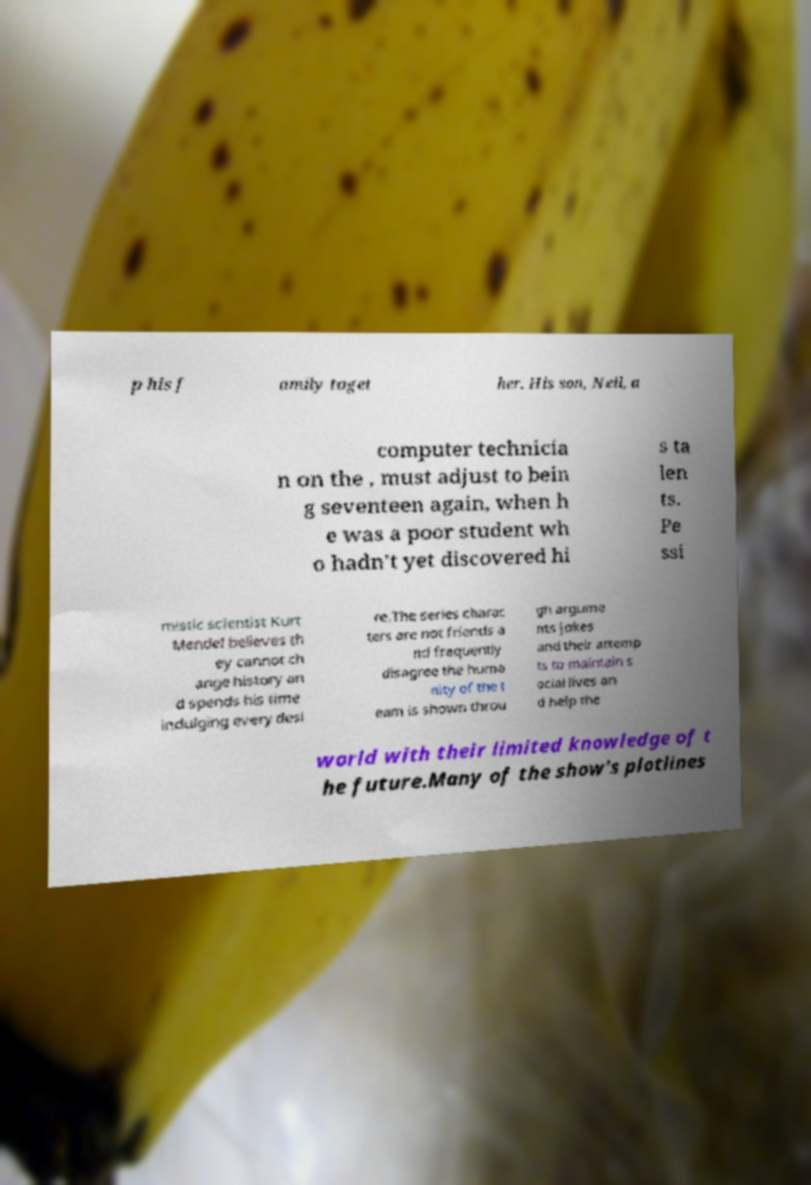Can you read and provide the text displayed in the image?This photo seems to have some interesting text. Can you extract and type it out for me? p his f amily toget her. His son, Neil, a computer technicia n on the , must adjust to bein g seventeen again, when h e was a poor student wh o hadn't yet discovered hi s ta len ts. Pe ssi mistic scientist Kurt Mendel believes th ey cannot ch ange history an d spends his time indulging every desi re.The series charac ters are not friends a nd frequently disagree the huma nity of the t eam is shown throu gh argume nts jokes and their attemp ts to maintain s ocial lives an d help the world with their limited knowledge of t he future.Many of the show's plotlines 